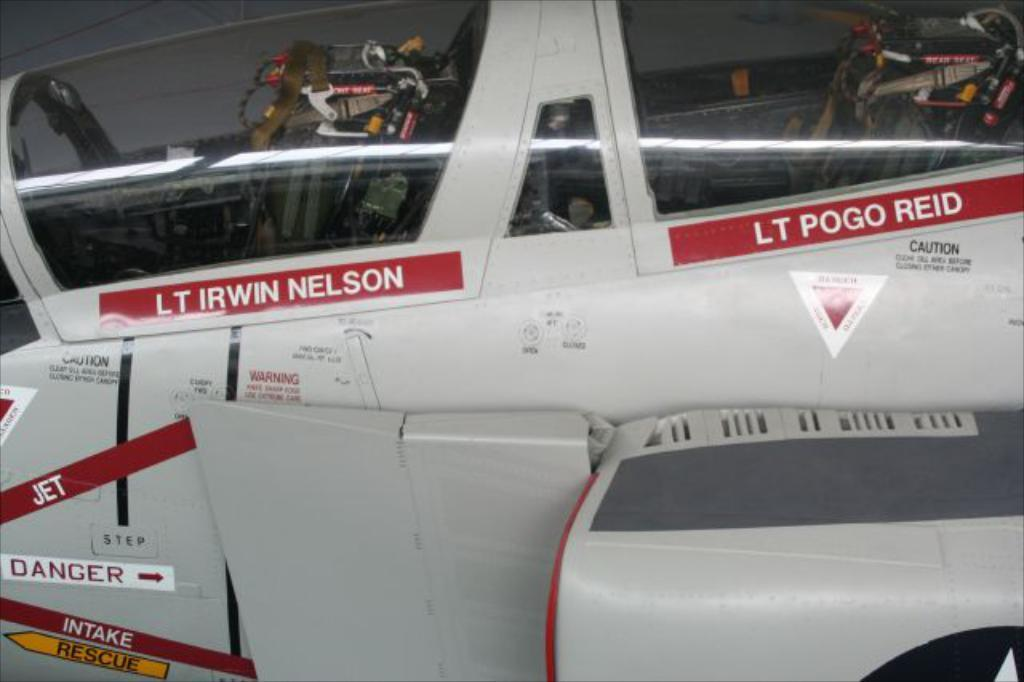<image>
Share a concise interpretation of the image provided. An aircraft has the names Lt. Irwin Nelson and Lt. Pogo Reid writen under the windows. 